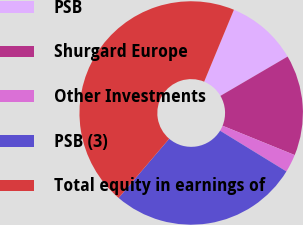Convert chart. <chart><loc_0><loc_0><loc_500><loc_500><pie_chart><fcel>PSB<fcel>Shurgard Europe<fcel>Other Investments<fcel>PSB (3)<fcel>Total equity in earnings of<nl><fcel>10.33%<fcel>14.57%<fcel>2.62%<fcel>27.49%<fcel>45.0%<nl></chart> 